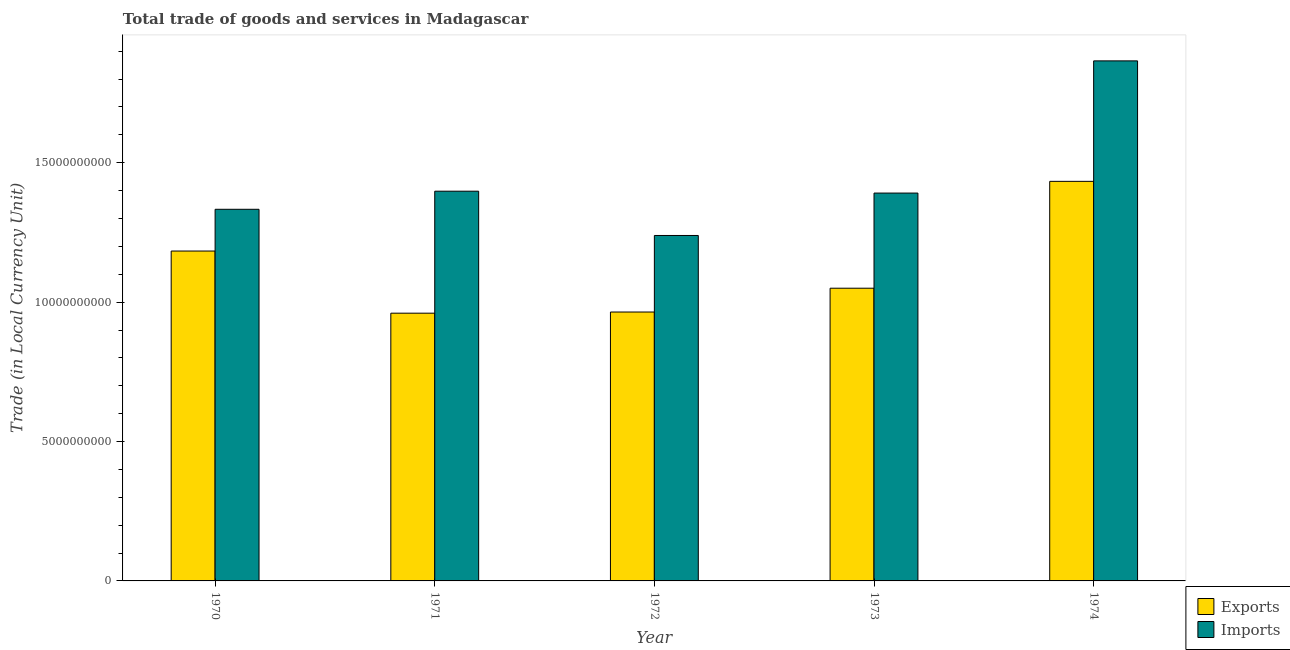How many different coloured bars are there?
Offer a very short reply. 2. How many groups of bars are there?
Keep it short and to the point. 5. Are the number of bars per tick equal to the number of legend labels?
Your response must be concise. Yes. Are the number of bars on each tick of the X-axis equal?
Make the answer very short. Yes. How many bars are there on the 2nd tick from the left?
Provide a short and direct response. 2. How many bars are there on the 1st tick from the right?
Your answer should be very brief. 2. What is the imports of goods and services in 1972?
Your answer should be compact. 1.24e+1. Across all years, what is the maximum imports of goods and services?
Offer a terse response. 1.87e+1. Across all years, what is the minimum imports of goods and services?
Ensure brevity in your answer.  1.24e+1. In which year was the imports of goods and services maximum?
Make the answer very short. 1974. In which year was the imports of goods and services minimum?
Provide a succinct answer. 1972. What is the total imports of goods and services in the graph?
Make the answer very short. 7.23e+1. What is the difference between the export of goods and services in 1970 and that in 1973?
Offer a terse response. 1.33e+09. What is the difference between the export of goods and services in 1973 and the imports of goods and services in 1974?
Your response must be concise. -3.83e+09. What is the average export of goods and services per year?
Offer a very short reply. 1.12e+1. In how many years, is the imports of goods and services greater than 13000000000 LCU?
Provide a short and direct response. 4. What is the ratio of the export of goods and services in 1971 to that in 1973?
Ensure brevity in your answer.  0.91. Is the export of goods and services in 1971 less than that in 1972?
Offer a terse response. Yes. What is the difference between the highest and the second highest imports of goods and services?
Offer a terse response. 4.67e+09. What is the difference between the highest and the lowest export of goods and services?
Your response must be concise. 4.73e+09. Is the sum of the imports of goods and services in 1970 and 1971 greater than the maximum export of goods and services across all years?
Offer a very short reply. Yes. What does the 1st bar from the left in 1972 represents?
Ensure brevity in your answer.  Exports. What does the 1st bar from the right in 1974 represents?
Give a very brief answer. Imports. How many years are there in the graph?
Offer a very short reply. 5. What is the difference between two consecutive major ticks on the Y-axis?
Provide a succinct answer. 5.00e+09. Are the values on the major ticks of Y-axis written in scientific E-notation?
Provide a short and direct response. No. Does the graph contain any zero values?
Your answer should be compact. No. How are the legend labels stacked?
Your answer should be compact. Vertical. What is the title of the graph?
Your response must be concise. Total trade of goods and services in Madagascar. Does "Methane" appear as one of the legend labels in the graph?
Offer a terse response. No. What is the label or title of the Y-axis?
Keep it short and to the point. Trade (in Local Currency Unit). What is the Trade (in Local Currency Unit) in Exports in 1970?
Your answer should be compact. 1.18e+1. What is the Trade (in Local Currency Unit) of Imports in 1970?
Offer a very short reply. 1.33e+1. What is the Trade (in Local Currency Unit) of Exports in 1971?
Your answer should be compact. 9.60e+09. What is the Trade (in Local Currency Unit) in Imports in 1971?
Keep it short and to the point. 1.40e+1. What is the Trade (in Local Currency Unit) in Exports in 1972?
Offer a very short reply. 9.65e+09. What is the Trade (in Local Currency Unit) in Imports in 1972?
Give a very brief answer. 1.24e+1. What is the Trade (in Local Currency Unit) of Exports in 1973?
Give a very brief answer. 1.05e+1. What is the Trade (in Local Currency Unit) in Imports in 1973?
Your answer should be very brief. 1.39e+1. What is the Trade (in Local Currency Unit) of Exports in 1974?
Provide a succinct answer. 1.43e+1. What is the Trade (in Local Currency Unit) of Imports in 1974?
Give a very brief answer. 1.87e+1. Across all years, what is the maximum Trade (in Local Currency Unit) in Exports?
Your answer should be very brief. 1.43e+1. Across all years, what is the maximum Trade (in Local Currency Unit) in Imports?
Your answer should be compact. 1.87e+1. Across all years, what is the minimum Trade (in Local Currency Unit) in Exports?
Your response must be concise. 9.60e+09. Across all years, what is the minimum Trade (in Local Currency Unit) of Imports?
Provide a succinct answer. 1.24e+1. What is the total Trade (in Local Currency Unit) in Exports in the graph?
Give a very brief answer. 5.59e+1. What is the total Trade (in Local Currency Unit) in Imports in the graph?
Your response must be concise. 7.23e+1. What is the difference between the Trade (in Local Currency Unit) of Exports in 1970 and that in 1971?
Your answer should be very brief. 2.23e+09. What is the difference between the Trade (in Local Currency Unit) in Imports in 1970 and that in 1971?
Offer a very short reply. -6.49e+08. What is the difference between the Trade (in Local Currency Unit) of Exports in 1970 and that in 1972?
Your answer should be compact. 2.19e+09. What is the difference between the Trade (in Local Currency Unit) in Imports in 1970 and that in 1972?
Offer a very short reply. 9.39e+08. What is the difference between the Trade (in Local Currency Unit) in Exports in 1970 and that in 1973?
Your response must be concise. 1.33e+09. What is the difference between the Trade (in Local Currency Unit) of Imports in 1970 and that in 1973?
Keep it short and to the point. -5.82e+08. What is the difference between the Trade (in Local Currency Unit) in Exports in 1970 and that in 1974?
Your response must be concise. -2.50e+09. What is the difference between the Trade (in Local Currency Unit) of Imports in 1970 and that in 1974?
Offer a very short reply. -5.32e+09. What is the difference between the Trade (in Local Currency Unit) in Exports in 1971 and that in 1972?
Your response must be concise. -4.17e+07. What is the difference between the Trade (in Local Currency Unit) of Imports in 1971 and that in 1972?
Give a very brief answer. 1.59e+09. What is the difference between the Trade (in Local Currency Unit) in Exports in 1971 and that in 1973?
Give a very brief answer. -8.96e+08. What is the difference between the Trade (in Local Currency Unit) of Imports in 1971 and that in 1973?
Give a very brief answer. 6.71e+07. What is the difference between the Trade (in Local Currency Unit) in Exports in 1971 and that in 1974?
Give a very brief answer. -4.73e+09. What is the difference between the Trade (in Local Currency Unit) of Imports in 1971 and that in 1974?
Keep it short and to the point. -4.67e+09. What is the difference between the Trade (in Local Currency Unit) in Exports in 1972 and that in 1973?
Your response must be concise. -8.54e+08. What is the difference between the Trade (in Local Currency Unit) in Imports in 1972 and that in 1973?
Your response must be concise. -1.52e+09. What is the difference between the Trade (in Local Currency Unit) of Exports in 1972 and that in 1974?
Give a very brief answer. -4.69e+09. What is the difference between the Trade (in Local Currency Unit) of Imports in 1972 and that in 1974?
Give a very brief answer. -6.26e+09. What is the difference between the Trade (in Local Currency Unit) of Exports in 1973 and that in 1974?
Provide a succinct answer. -3.83e+09. What is the difference between the Trade (in Local Currency Unit) of Imports in 1973 and that in 1974?
Provide a short and direct response. -4.74e+09. What is the difference between the Trade (in Local Currency Unit) in Exports in 1970 and the Trade (in Local Currency Unit) in Imports in 1971?
Provide a succinct answer. -2.15e+09. What is the difference between the Trade (in Local Currency Unit) of Exports in 1970 and the Trade (in Local Currency Unit) of Imports in 1972?
Your response must be concise. -5.58e+08. What is the difference between the Trade (in Local Currency Unit) in Exports in 1970 and the Trade (in Local Currency Unit) in Imports in 1973?
Provide a short and direct response. -2.08e+09. What is the difference between the Trade (in Local Currency Unit) in Exports in 1970 and the Trade (in Local Currency Unit) in Imports in 1974?
Give a very brief answer. -6.82e+09. What is the difference between the Trade (in Local Currency Unit) of Exports in 1971 and the Trade (in Local Currency Unit) of Imports in 1972?
Your answer should be compact. -2.79e+09. What is the difference between the Trade (in Local Currency Unit) in Exports in 1971 and the Trade (in Local Currency Unit) in Imports in 1973?
Your answer should be very brief. -4.31e+09. What is the difference between the Trade (in Local Currency Unit) of Exports in 1971 and the Trade (in Local Currency Unit) of Imports in 1974?
Provide a succinct answer. -9.05e+09. What is the difference between the Trade (in Local Currency Unit) in Exports in 1972 and the Trade (in Local Currency Unit) in Imports in 1973?
Make the answer very short. -4.27e+09. What is the difference between the Trade (in Local Currency Unit) in Exports in 1972 and the Trade (in Local Currency Unit) in Imports in 1974?
Your answer should be compact. -9.01e+09. What is the difference between the Trade (in Local Currency Unit) in Exports in 1973 and the Trade (in Local Currency Unit) in Imports in 1974?
Give a very brief answer. -8.15e+09. What is the average Trade (in Local Currency Unit) of Exports per year?
Provide a succinct answer. 1.12e+1. What is the average Trade (in Local Currency Unit) in Imports per year?
Provide a succinct answer. 1.45e+1. In the year 1970, what is the difference between the Trade (in Local Currency Unit) in Exports and Trade (in Local Currency Unit) in Imports?
Provide a short and direct response. -1.50e+09. In the year 1971, what is the difference between the Trade (in Local Currency Unit) in Exports and Trade (in Local Currency Unit) in Imports?
Your response must be concise. -4.38e+09. In the year 1972, what is the difference between the Trade (in Local Currency Unit) in Exports and Trade (in Local Currency Unit) in Imports?
Offer a very short reply. -2.75e+09. In the year 1973, what is the difference between the Trade (in Local Currency Unit) of Exports and Trade (in Local Currency Unit) of Imports?
Offer a very short reply. -3.41e+09. In the year 1974, what is the difference between the Trade (in Local Currency Unit) of Exports and Trade (in Local Currency Unit) of Imports?
Your answer should be very brief. -4.32e+09. What is the ratio of the Trade (in Local Currency Unit) in Exports in 1970 to that in 1971?
Make the answer very short. 1.23. What is the ratio of the Trade (in Local Currency Unit) of Imports in 1970 to that in 1971?
Give a very brief answer. 0.95. What is the ratio of the Trade (in Local Currency Unit) of Exports in 1970 to that in 1972?
Provide a succinct answer. 1.23. What is the ratio of the Trade (in Local Currency Unit) in Imports in 1970 to that in 1972?
Your answer should be compact. 1.08. What is the ratio of the Trade (in Local Currency Unit) of Exports in 1970 to that in 1973?
Your answer should be compact. 1.13. What is the ratio of the Trade (in Local Currency Unit) in Imports in 1970 to that in 1973?
Provide a short and direct response. 0.96. What is the ratio of the Trade (in Local Currency Unit) in Exports in 1970 to that in 1974?
Your response must be concise. 0.83. What is the ratio of the Trade (in Local Currency Unit) in Imports in 1970 to that in 1974?
Your answer should be compact. 0.71. What is the ratio of the Trade (in Local Currency Unit) in Exports in 1971 to that in 1972?
Provide a succinct answer. 1. What is the ratio of the Trade (in Local Currency Unit) of Imports in 1971 to that in 1972?
Your response must be concise. 1.13. What is the ratio of the Trade (in Local Currency Unit) of Exports in 1971 to that in 1973?
Give a very brief answer. 0.91. What is the ratio of the Trade (in Local Currency Unit) in Imports in 1971 to that in 1973?
Offer a very short reply. 1. What is the ratio of the Trade (in Local Currency Unit) in Exports in 1971 to that in 1974?
Give a very brief answer. 0.67. What is the ratio of the Trade (in Local Currency Unit) of Imports in 1971 to that in 1974?
Offer a very short reply. 0.75. What is the ratio of the Trade (in Local Currency Unit) of Exports in 1972 to that in 1973?
Offer a terse response. 0.92. What is the ratio of the Trade (in Local Currency Unit) in Imports in 1972 to that in 1973?
Give a very brief answer. 0.89. What is the ratio of the Trade (in Local Currency Unit) of Exports in 1972 to that in 1974?
Keep it short and to the point. 0.67. What is the ratio of the Trade (in Local Currency Unit) of Imports in 1972 to that in 1974?
Provide a succinct answer. 0.66. What is the ratio of the Trade (in Local Currency Unit) in Exports in 1973 to that in 1974?
Your response must be concise. 0.73. What is the ratio of the Trade (in Local Currency Unit) in Imports in 1973 to that in 1974?
Your response must be concise. 0.75. What is the difference between the highest and the second highest Trade (in Local Currency Unit) in Exports?
Ensure brevity in your answer.  2.50e+09. What is the difference between the highest and the second highest Trade (in Local Currency Unit) in Imports?
Offer a very short reply. 4.67e+09. What is the difference between the highest and the lowest Trade (in Local Currency Unit) of Exports?
Ensure brevity in your answer.  4.73e+09. What is the difference between the highest and the lowest Trade (in Local Currency Unit) in Imports?
Your response must be concise. 6.26e+09. 